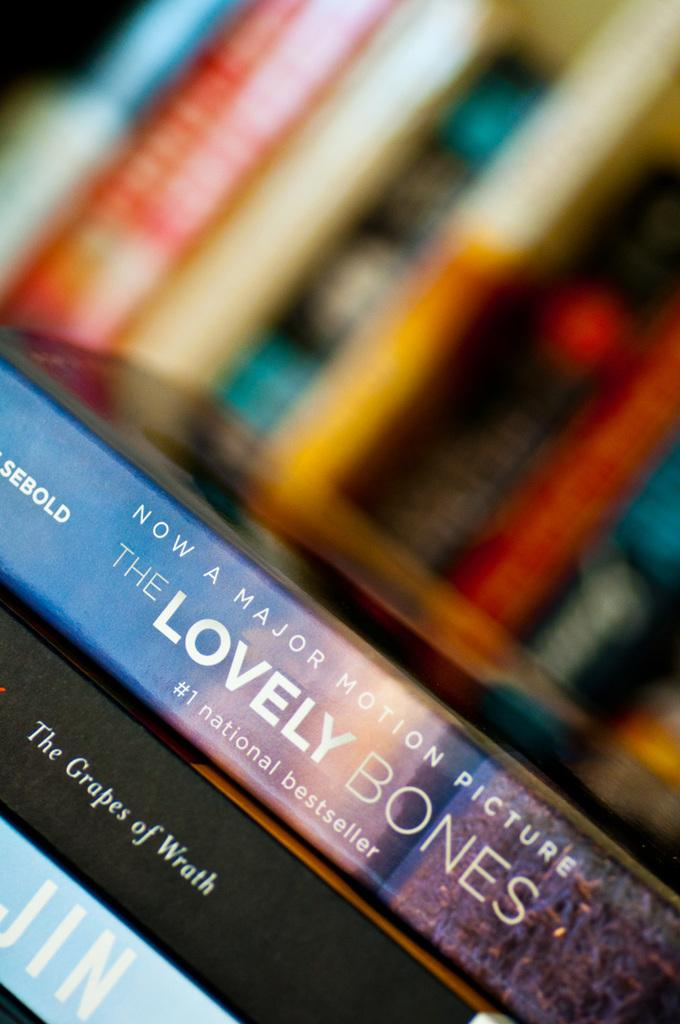<image>
Give a short and clear explanation of the subsequent image. The book The Lovely Bones sits atop a pile of other books. 